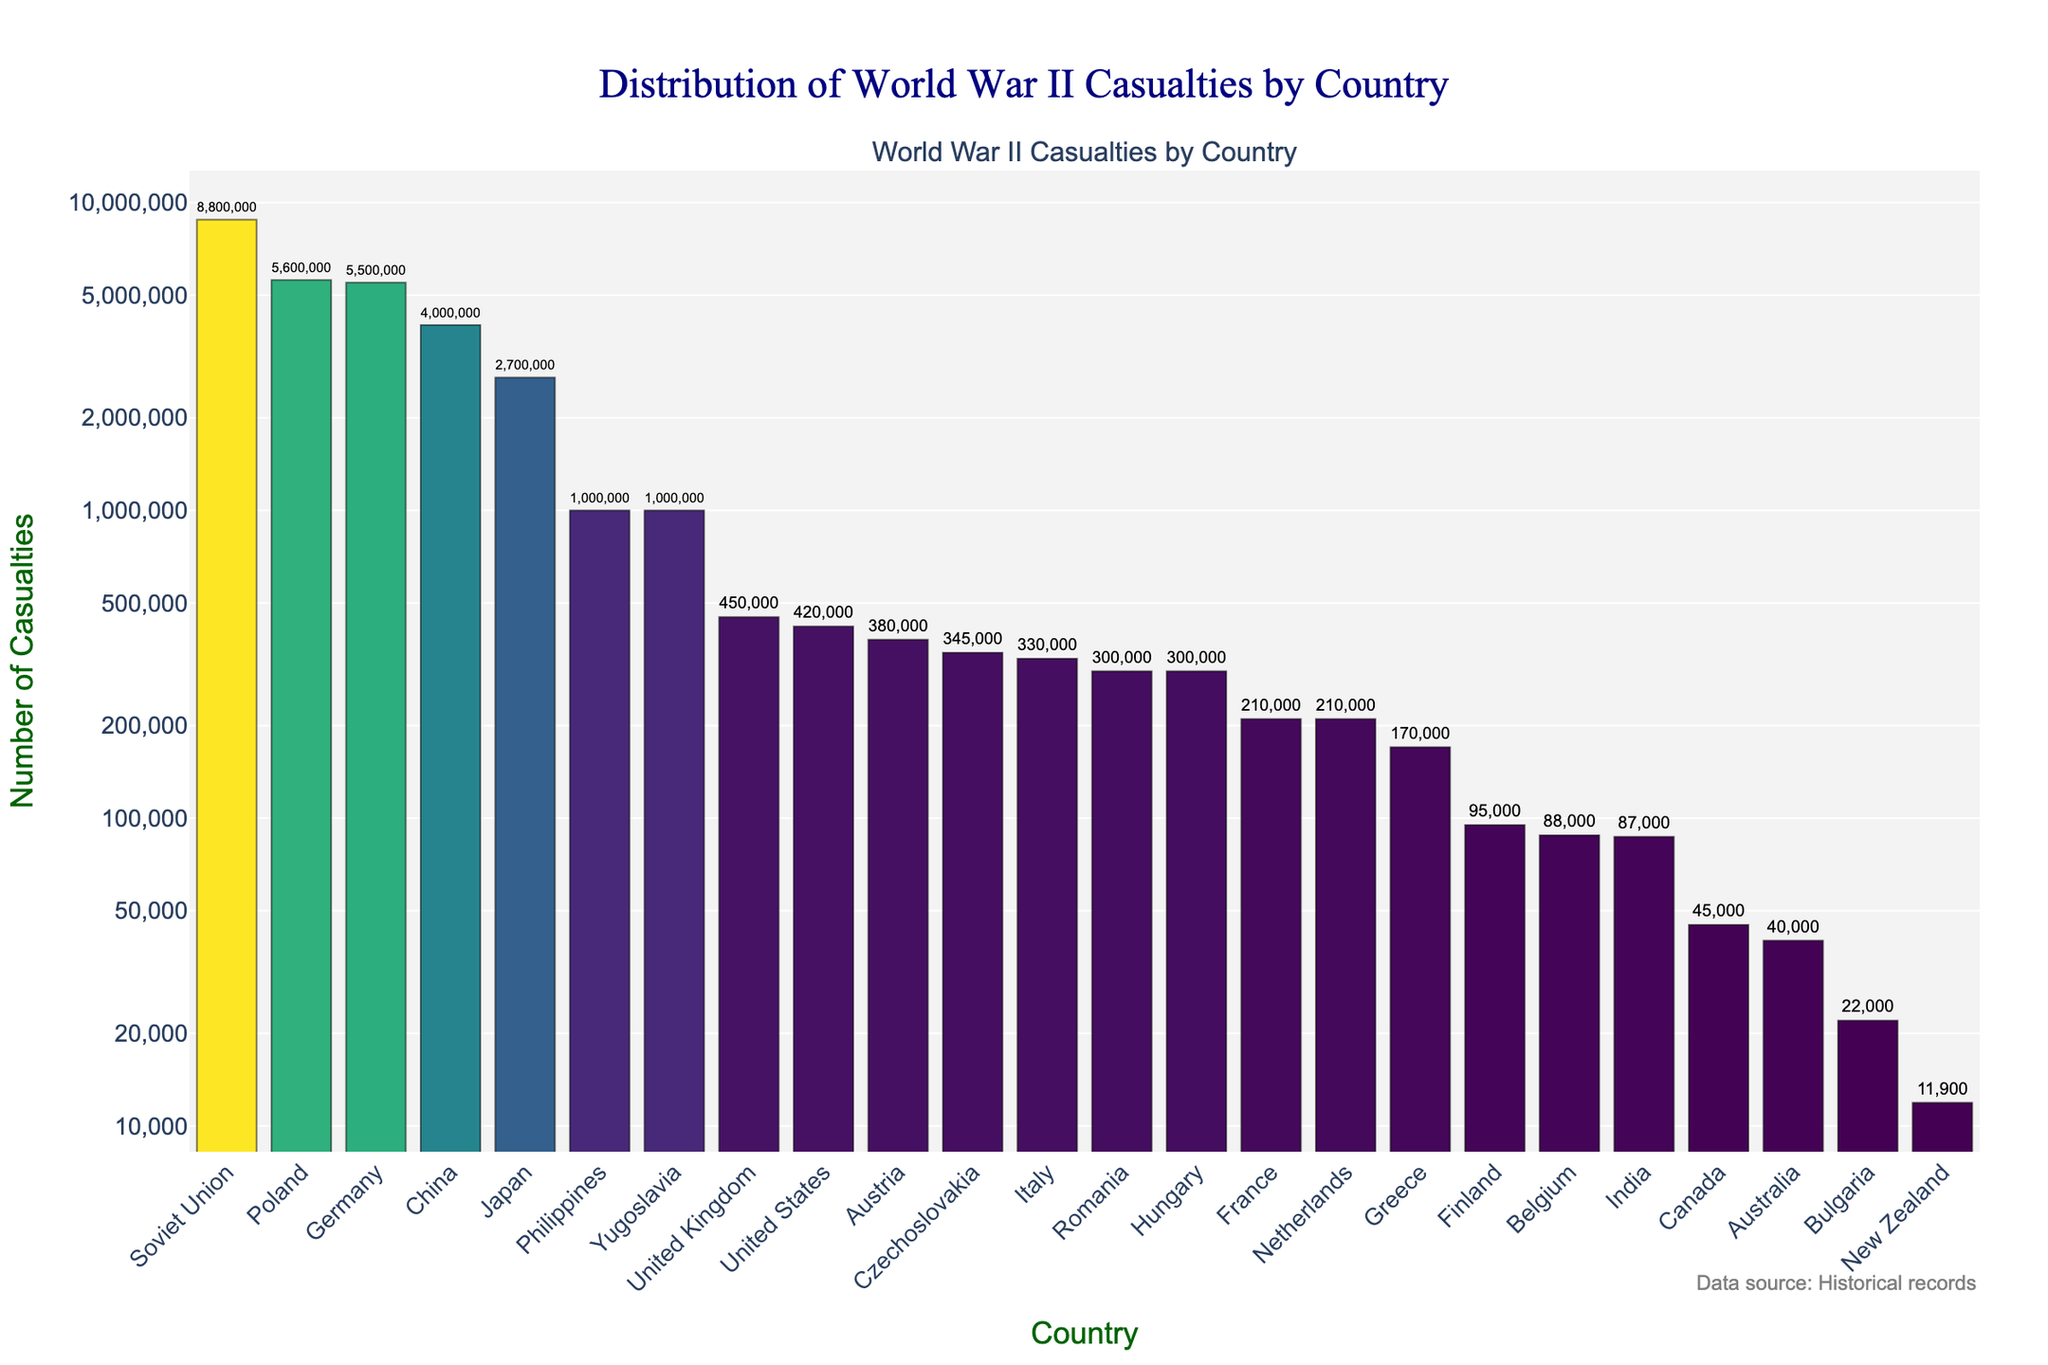Which country experienced the highest number of casualties? Look for the bar with the highest value on the y-axis and read the corresponding country on the x-axis.
Answer: Soviet Union How many more casualties did Poland have compared to China? Find the casualties for Poland (5,600,000) and China (4,000,000), then subtract China's casualties from Poland's casualties: 5,600,000 - 4,000,000.
Answer: 1,600,000 Which theater of war had the most casualties for the United States? Refer to the hover text of the United States bar, which provides details about the theater of war where their casualties occurred.
Answer: Multiple Theaters Compare the total number of casualties between Japan and Germany. Which country had fewer casualties, and by how much? Find the casualties for Japan (2,700,000) and Germany (5,500,000), then subtract Japan's casualties from Germany's: 5,500,000 - 2,700,000.
Answer: Japan, by 2,800,000 What is the average number of casualties among the countries with fewer than 100,000 casualties? Identify the countries with casualties below 100,000: Finland (95,000), India (87,000), Bulgaria (22,000), New Zealand (11,900). Add these values: 95,000 + 87,000 + 22,000 + 11,900 = 215,900, then divide by 4.
Answer: 53,975 How many countries have casualties greater than 1,000,000? Count the number of bars where the y-value (casualties) exceeds 1,000,000.
Answer: 6 countries What is the difference in casualties between the Eastern Front and Pacific theaters for all countries combined? Sum the casualties for countries in the Eastern Front: Soviet Union (8,800,000), Poland (5,600,000), Romania (300,000), Hungary (300,000), Finland (95,000), Czechoslovakia (345,000). The sum is 8,800,000 + 5,600,000 + 300,000 + 300,000 + 95,000 + 345,000 = 15,440,000. Sum the casualties for countries in the Pacific theater: China (4,000,000), Japan (2,700,000), Australia (40,000), New Zealand (11,900). The sum is 4,000,000 + 2,700,000 + 40,000 + 11,900 = 6,751,900. Subtract Pacific theater from Eastern Front: 15,440,000 - 6,751,900.
Answer: 8,688,100 Which country had the smallest number of casualties in the graph? Identify the bar with the smallest value on the y-axis and read the corresponding country on the x-axis.
Answer: New Zealand Compare Greece and Belgium casualties. Which country had more casualties and by how much? Look for Greece's (170,000) and Belgium's (88,000) casualties, then subtract Belgium's casualties from Greece's: 170,000 - 88,000.
Answer: Greece, by 82,000 